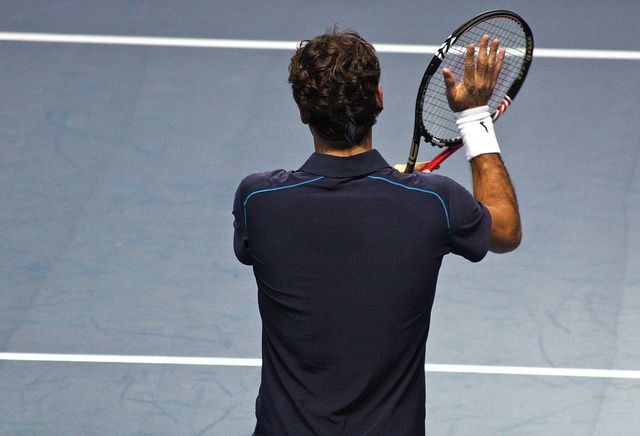Describe the objects in this image and their specific colors. I can see people in gray, black, maroon, and darkgray tones and tennis racket in gray, darkgray, and black tones in this image. 